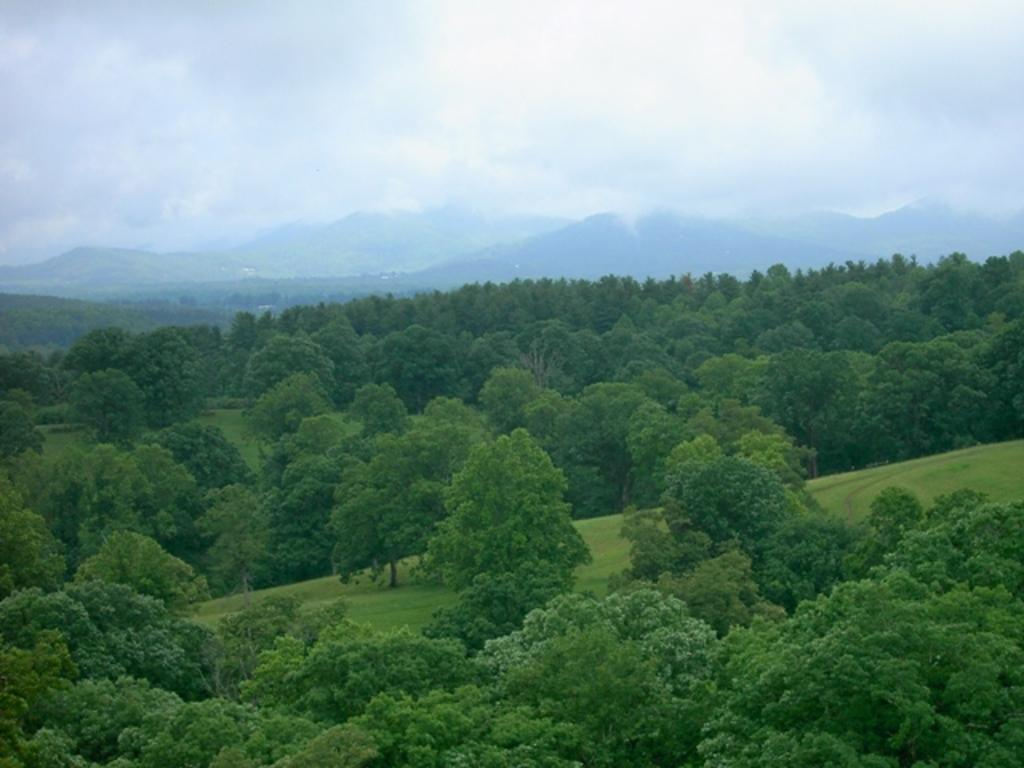What type of vegetation can be seen in the image? There are trees in the image. What can be seen in the distance in the image? There are hills in the background of the image. What is the weather like in the image? The fog in the background of the image suggests a misty or foggy day. What part of the natural environment is visible in the image? The sky is visible in the image, and clouds are present in the sky. Where is the chin located in the image? There is no chin present in the image. Can you describe the stream that flows through the trees in the image? There is no stream present in the image; it only features trees, hills, fog, sky, and clouds. 